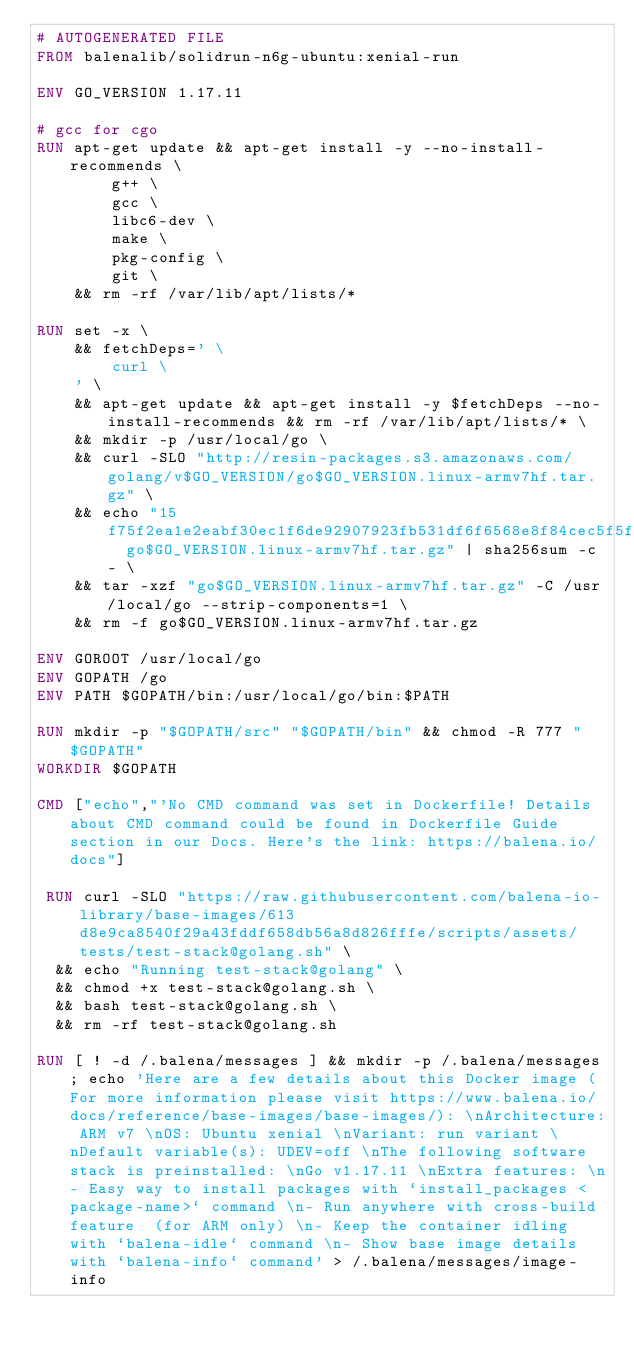<code> <loc_0><loc_0><loc_500><loc_500><_Dockerfile_># AUTOGENERATED FILE
FROM balenalib/solidrun-n6g-ubuntu:xenial-run

ENV GO_VERSION 1.17.11

# gcc for cgo
RUN apt-get update && apt-get install -y --no-install-recommends \
		g++ \
		gcc \
		libc6-dev \
		make \
		pkg-config \
		git \
	&& rm -rf /var/lib/apt/lists/*

RUN set -x \
	&& fetchDeps=' \
		curl \
	' \
	&& apt-get update && apt-get install -y $fetchDeps --no-install-recommends && rm -rf /var/lib/apt/lists/* \
	&& mkdir -p /usr/local/go \
	&& curl -SLO "http://resin-packages.s3.amazonaws.com/golang/v$GO_VERSION/go$GO_VERSION.linux-armv7hf.tar.gz" \
	&& echo "15f75f2ea1e2eabf30ec1f6de92907923fb531df6f6568e8f84cec5f5f5c9e8d  go$GO_VERSION.linux-armv7hf.tar.gz" | sha256sum -c - \
	&& tar -xzf "go$GO_VERSION.linux-armv7hf.tar.gz" -C /usr/local/go --strip-components=1 \
	&& rm -f go$GO_VERSION.linux-armv7hf.tar.gz

ENV GOROOT /usr/local/go
ENV GOPATH /go
ENV PATH $GOPATH/bin:/usr/local/go/bin:$PATH

RUN mkdir -p "$GOPATH/src" "$GOPATH/bin" && chmod -R 777 "$GOPATH"
WORKDIR $GOPATH

CMD ["echo","'No CMD command was set in Dockerfile! Details about CMD command could be found in Dockerfile Guide section in our Docs. Here's the link: https://balena.io/docs"]

 RUN curl -SLO "https://raw.githubusercontent.com/balena-io-library/base-images/613d8e9ca8540f29a43fddf658db56a8d826fffe/scripts/assets/tests/test-stack@golang.sh" \
  && echo "Running test-stack@golang" \
  && chmod +x test-stack@golang.sh \
  && bash test-stack@golang.sh \
  && rm -rf test-stack@golang.sh 

RUN [ ! -d /.balena/messages ] && mkdir -p /.balena/messages; echo 'Here are a few details about this Docker image (For more information please visit https://www.balena.io/docs/reference/base-images/base-images/): \nArchitecture: ARM v7 \nOS: Ubuntu xenial \nVariant: run variant \nDefault variable(s): UDEV=off \nThe following software stack is preinstalled: \nGo v1.17.11 \nExtra features: \n- Easy way to install packages with `install_packages <package-name>` command \n- Run anywhere with cross-build feature  (for ARM only) \n- Keep the container idling with `balena-idle` command \n- Show base image details with `balena-info` command' > /.balena/messages/image-info</code> 